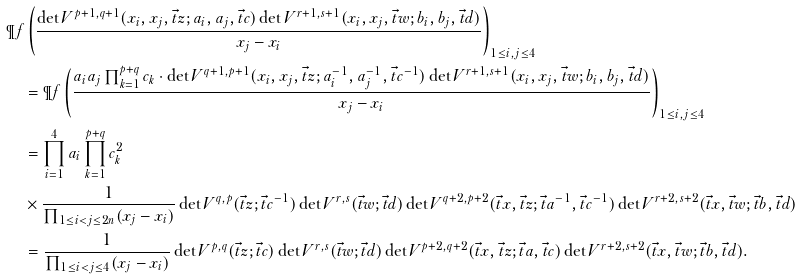Convert formula to latex. <formula><loc_0><loc_0><loc_500><loc_500>& \P f \left ( \frac { \det V ^ { p + 1 , q + 1 } ( x _ { i } , x _ { j } , \vec { t } z ; a _ { i } , a _ { j } , \vec { t } c ) \det V ^ { r + 1 , s + 1 } ( x _ { i } , x _ { j } , \vec { t } w ; b _ { i } , b _ { j } , \vec { t } d ) } { x _ { j } - x _ { i } } \right ) _ { 1 \leq i , j \leq 4 } \\ & \quad = \P f \left ( \frac { a _ { i } a _ { j } \prod _ { k = 1 } ^ { p + q } c _ { k } \cdot \det V ^ { q + 1 , p + 1 } ( x _ { i } , x _ { j } , \vec { t } z ; a _ { i } ^ { - 1 } , a _ { j } ^ { - 1 } , \vec { t } c ^ { - 1 } ) \det V ^ { r + 1 , s + 1 } ( x _ { i } , x _ { j } , \vec { t } w ; b _ { i } , b _ { j } , \vec { t } d ) } { x _ { j } - x _ { i } } \right ) _ { 1 \leq i , j \leq 4 } \\ & \quad = \prod _ { i = 1 } ^ { 4 } a _ { i } \prod _ { k = 1 } ^ { p + q } c _ { k } ^ { 2 } \\ & \quad \times \frac { 1 } { \prod _ { 1 \leq i < j \leq 2 n } ( x _ { j } - x _ { i } ) } \det V ^ { q , p } ( \vec { t } z ; \vec { t } c ^ { - 1 } ) \det V ^ { r , s } ( \vec { t } w ; \vec { t } d ) \det V ^ { q + 2 , p + 2 } ( \vec { t } x , \vec { t } z ; \vec { t } a ^ { - 1 } , \vec { t } c ^ { - 1 } ) \det V ^ { r + 2 , s + 2 } ( \vec { t } x , \vec { t } w ; \vec { t } b , \vec { t } d ) \\ & \quad = \frac { 1 } { \prod _ { 1 \leq i < j \leq 4 } ( x _ { j } - x _ { i } ) } \det V ^ { p , q } ( \vec { t } z ; \vec { t } c ) \det V ^ { r , s } ( \vec { t } w ; \vec { t } d ) \det V ^ { p + 2 , q + 2 } ( \vec { t } x , \vec { t } z ; \vec { t } a , \vec { t } c ) \det V ^ { r + 2 , s + 2 } ( \vec { t } x , \vec { t } w ; \vec { t } b , \vec { t } d ) .</formula> 